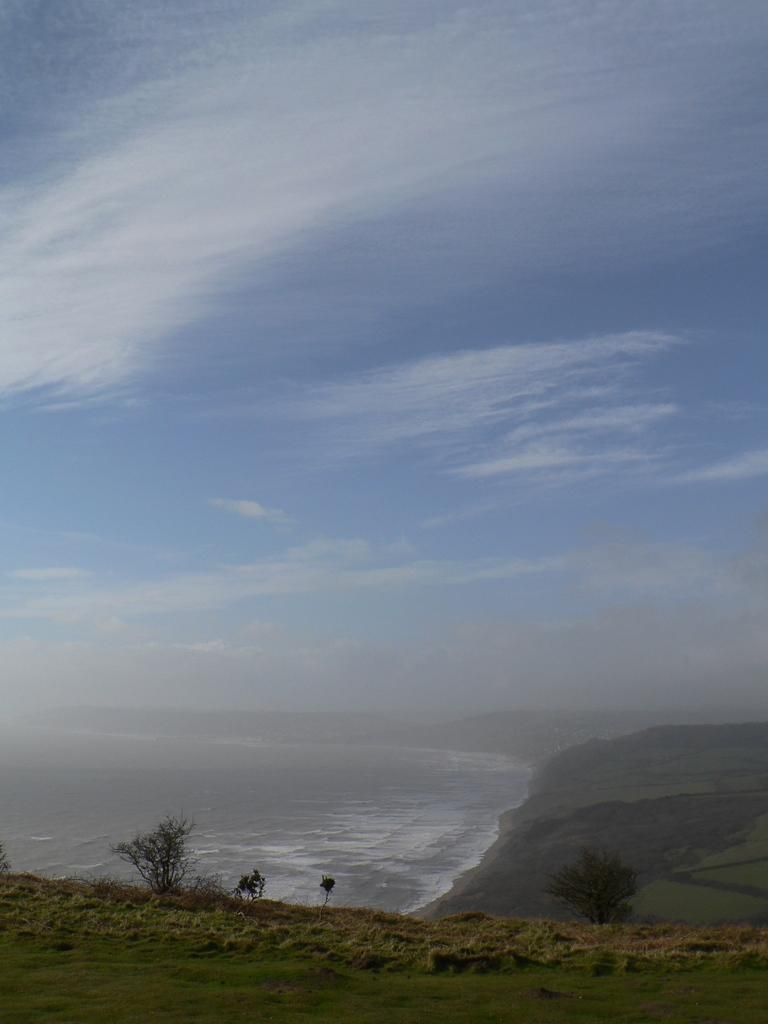What type of surface can be seen in the image? Ground is visible in the image. What type of vegetation is present in the image? There is grass and plants in the image. What can be seen in the background of the image? There is water, trees, and the sky visible in the background of the image. Can you see a needle being used in the image? There is no needle present in the image. Is there a chess game happening in the image? There is no chess game or any reference to chess in the image. 